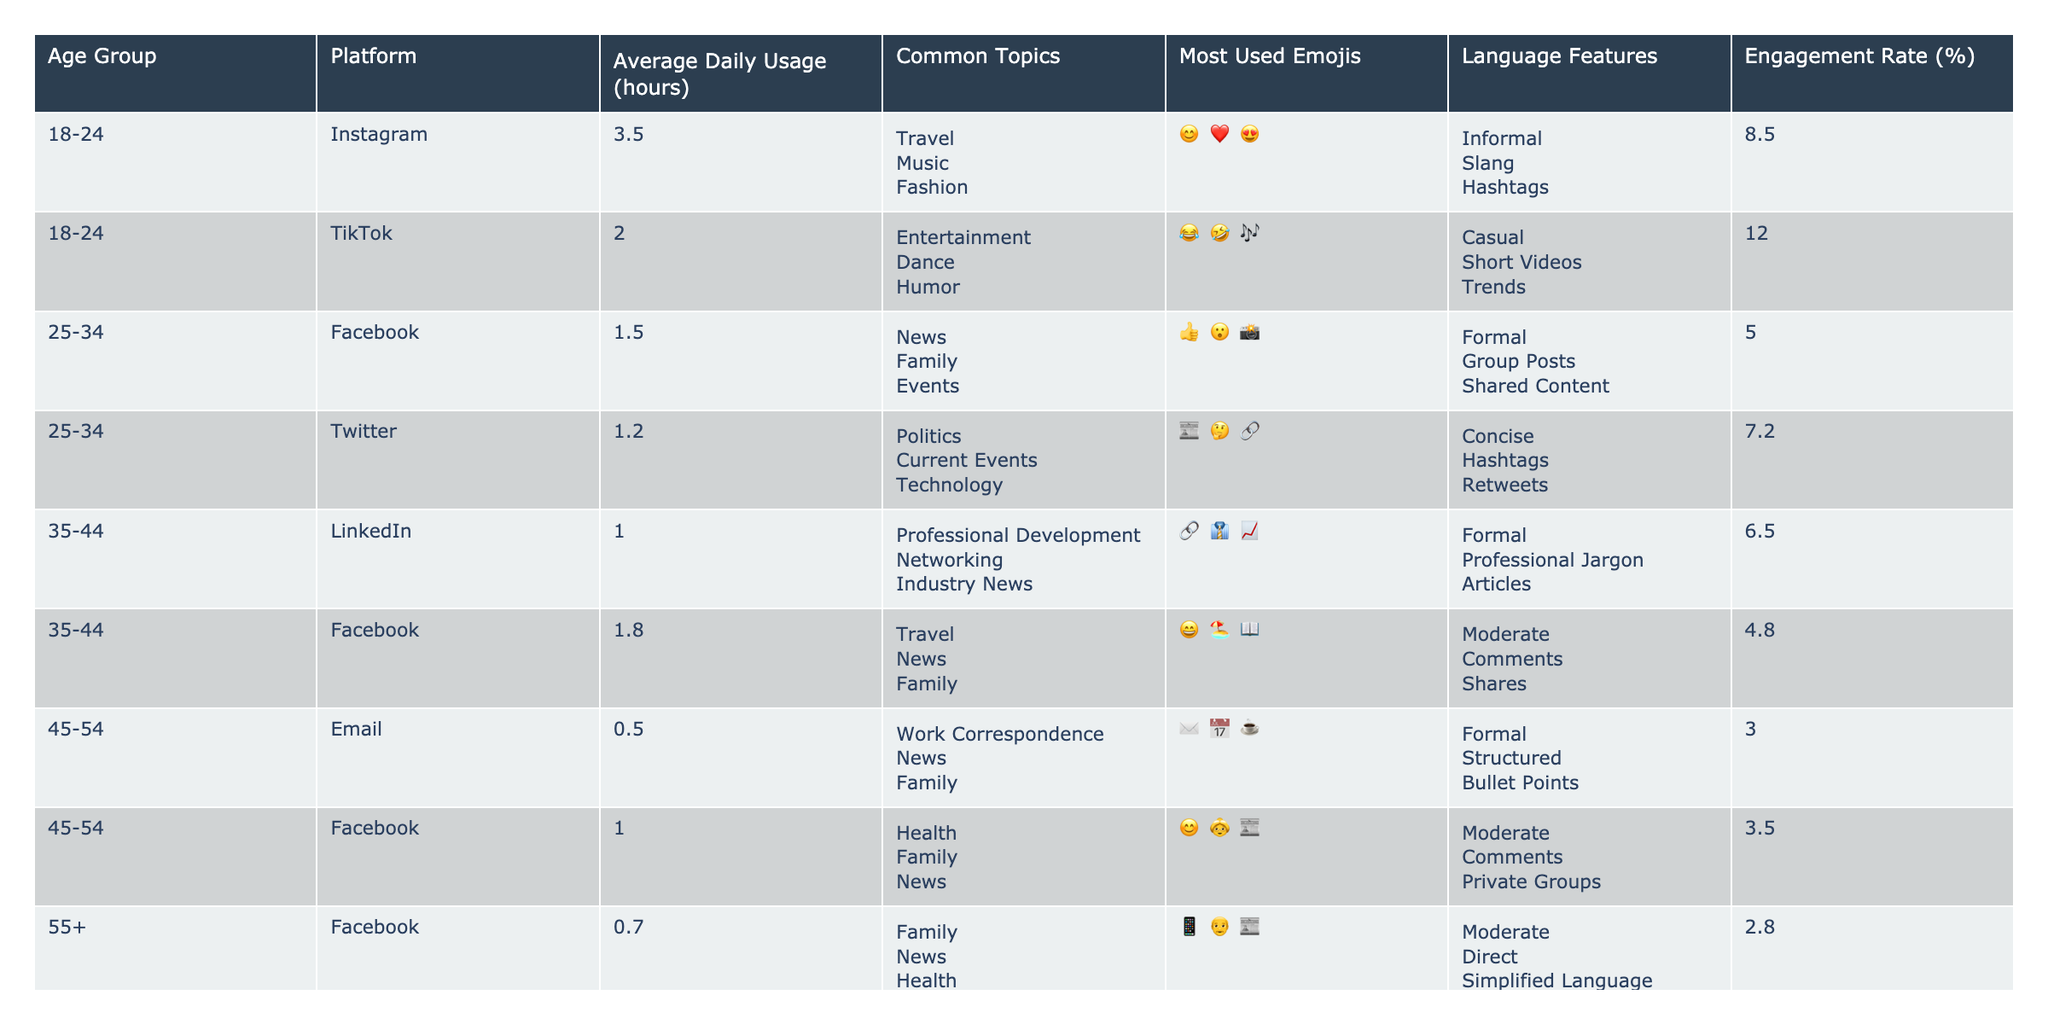What is the average daily usage of social media for the age group 35-44? Looking at the table, the age group 35-44 has two entries: LinkedIn with 1.0 hours and Facebook with 1.8 hours. To find the average, sum these values: 1.0 + 1.8 = 2.8. Then divide by the number of platforms (2): 2.8 / 2 = 1.4 hours.
Answer: 1.4 hours Which platform has the highest average daily usage among the 18-24 age group? Referring to the table, for the 18-24 age group, Instagram has an average daily usage of 3.5 hours, and TikTok has 2.0 hours. Comparing these values shows that Instagram has the highest usage.
Answer: Instagram Is it true that the engagement rate for users aged 45-54 is higher on Facebook than on Email? The engagement rates for Facebook (3.5%) and Email (2.0%) are provided in the table. Since 3.5% is greater than 2.0%, it confirms that the engagement rate is indeed higher on Facebook.
Answer: Yes What is the total average daily usage of social media across all age groups? To calculate the total average, sum all average daily usage hours from the table, which are as follows: 3.5 (Instagram) + 2.0 (TikTok) + 1.5 (Facebook) + 1.2 (Twitter) + 1.0 (LinkedIn) + 1.8 (Facebook) + 0.5 (Email) + 1.0 (Facebook) + 0.7 (Facebook) + 0.4 (Email) = 13.1 hours. Then divide by the number of entries (10): 13.1 / 10 = 1.31 hours.
Answer: 1.31 hours Which age group is most likely to use TikTok? The table shows that TikTok is listed under the age group 18-24 only. Therefore, this age group is the most likely to use TikTok as it is the only group associated with that platform.
Answer: 18-24 What is the most used emoji among users aged 25-34 on Facebook? In the table, under the age group 25-34 for Facebook, the most used emojis are listed as "👍; 😮; 📸". The first emoji listed (👍) is the most used.
Answer: 👍 What is the engagement rate for users aged 55+ on Facebook? The table shows that the engagement rate for users aged 55+ on Facebook is 2.8%. This is a direct value indicated in the table under the respective age group and platform.
Answer: 2.8% Calculate the difference in average daily usage between the 18-24 and the 45-54 age groups. For 18-24, the average usage is 3.5 (Instagram) + 2.0 (TikTok) = 5.5 hours, divided by 2 gives 2.75 hours. For 45-54, usage is 0.5 (Email) + 1.0 (Facebook) = 1.5 hours, divided by 2 gives 0.75 hours. The difference is 2.75 - 0.75 = 2.0 hours.
Answer: 2.0 hours How many different platforms do users aged 35-44 engage with according to the table? The age group 35-44 in the table shows two different platforms: LinkedIn and Facebook. Therefore, they engage with a total of two distinct platforms.
Answer: 2 Which age group uses the most diverse range of topics in their social media usage? Looking at the "Common Topics" column, the 18-24 age group has three topics listed (Travel, Music, Fashion), while the 25-34 group also has three (News, Family, Events). The other groups have fewer, with the 35-44 group having three, and the 55+ groups having three or fewer. Both 18-24 and 25-34 have the highest diversity, tied with three topics each.
Answer: 18-24 and 25-34 